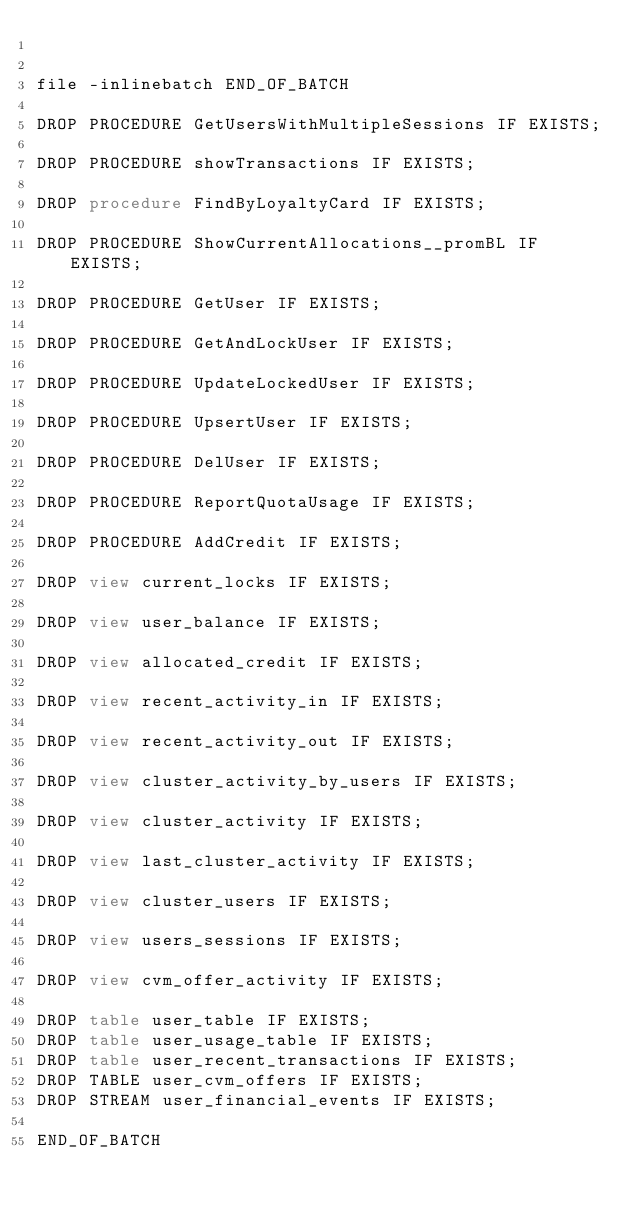<code> <loc_0><loc_0><loc_500><loc_500><_SQL_>

file -inlinebatch END_OF_BATCH

DROP PROCEDURE GetUsersWithMultipleSessions IF EXISTS;

DROP PROCEDURE showTransactions IF EXISTS;

DROP procedure FindByLoyaltyCard IF EXISTS;

DROP PROCEDURE ShowCurrentAllocations__promBL IF EXISTS;

DROP PROCEDURE GetUser IF EXISTS;
   
DROP PROCEDURE GetAndLockUser IF EXISTS;
   
DROP PROCEDURE UpdateLockedUser IF EXISTS;
   
DROP PROCEDURE UpsertUser IF EXISTS;
   
DROP PROCEDURE DelUser IF EXISTS;
   
DROP PROCEDURE ReportQuotaUsage IF EXISTS;  
   
DROP PROCEDURE AddCredit IF EXISTS;  

DROP view current_locks IF EXISTS; 

DROP view user_balance IF EXISTS; 

DROP view allocated_credit IF EXISTS;

DROP view recent_activity_in IF EXISTS;

DROP view recent_activity_out IF EXISTS;

DROP view cluster_activity_by_users IF EXISTS;

DROP view cluster_activity IF EXISTS;

DROP view last_cluster_activity IF EXISTS;

DROP view cluster_users IF EXISTS;

DROP view users_sessions IF EXISTS;

DROP view cvm_offer_activity IF EXISTS;
   
DROP table user_table IF EXISTS;
DROP table user_usage_table IF EXISTS;
DROP table user_recent_transactions IF EXISTS;
DROP TABLE user_cvm_offers IF EXISTS;
DROP STREAM user_financial_events IF EXISTS;

END_OF_BATCH
</code> 